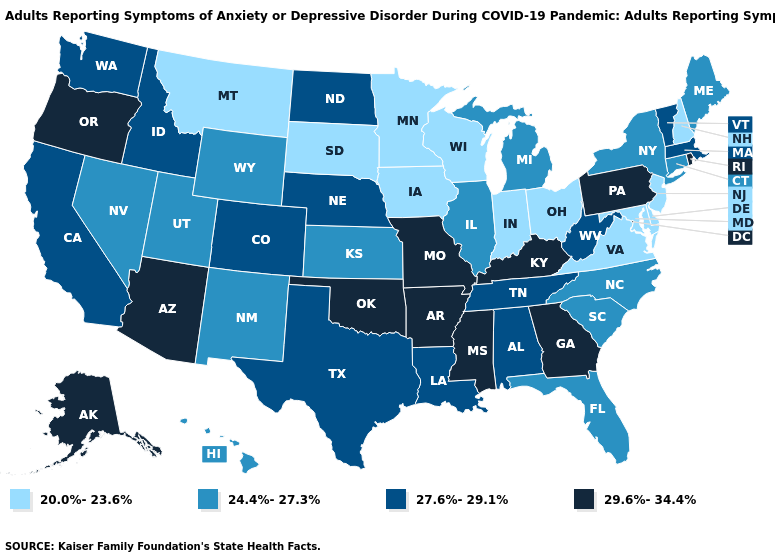What is the highest value in states that border Massachusetts?
Quick response, please. 29.6%-34.4%. Does North Carolina have the highest value in the USA?
Keep it brief. No. Name the states that have a value in the range 24.4%-27.3%?
Keep it brief. Connecticut, Florida, Hawaii, Illinois, Kansas, Maine, Michigan, Nevada, New Mexico, New York, North Carolina, South Carolina, Utah, Wyoming. Does Maryland have the lowest value in the South?
Keep it brief. Yes. What is the value of Kentucky?
Write a very short answer. 29.6%-34.4%. What is the value of Texas?
Be succinct. 27.6%-29.1%. What is the value of Kentucky?
Concise answer only. 29.6%-34.4%. Name the states that have a value in the range 27.6%-29.1%?
Quick response, please. Alabama, California, Colorado, Idaho, Louisiana, Massachusetts, Nebraska, North Dakota, Tennessee, Texas, Vermont, Washington, West Virginia. Does Connecticut have the highest value in the Northeast?
Write a very short answer. No. Name the states that have a value in the range 20.0%-23.6%?
Quick response, please. Delaware, Indiana, Iowa, Maryland, Minnesota, Montana, New Hampshire, New Jersey, Ohio, South Dakota, Virginia, Wisconsin. What is the value of Ohio?
Be succinct. 20.0%-23.6%. Which states have the highest value in the USA?
Quick response, please. Alaska, Arizona, Arkansas, Georgia, Kentucky, Mississippi, Missouri, Oklahoma, Oregon, Pennsylvania, Rhode Island. Does Kansas have the highest value in the USA?
Concise answer only. No. Name the states that have a value in the range 27.6%-29.1%?
Keep it brief. Alabama, California, Colorado, Idaho, Louisiana, Massachusetts, Nebraska, North Dakota, Tennessee, Texas, Vermont, Washington, West Virginia. Does Colorado have the lowest value in the USA?
Give a very brief answer. No. 